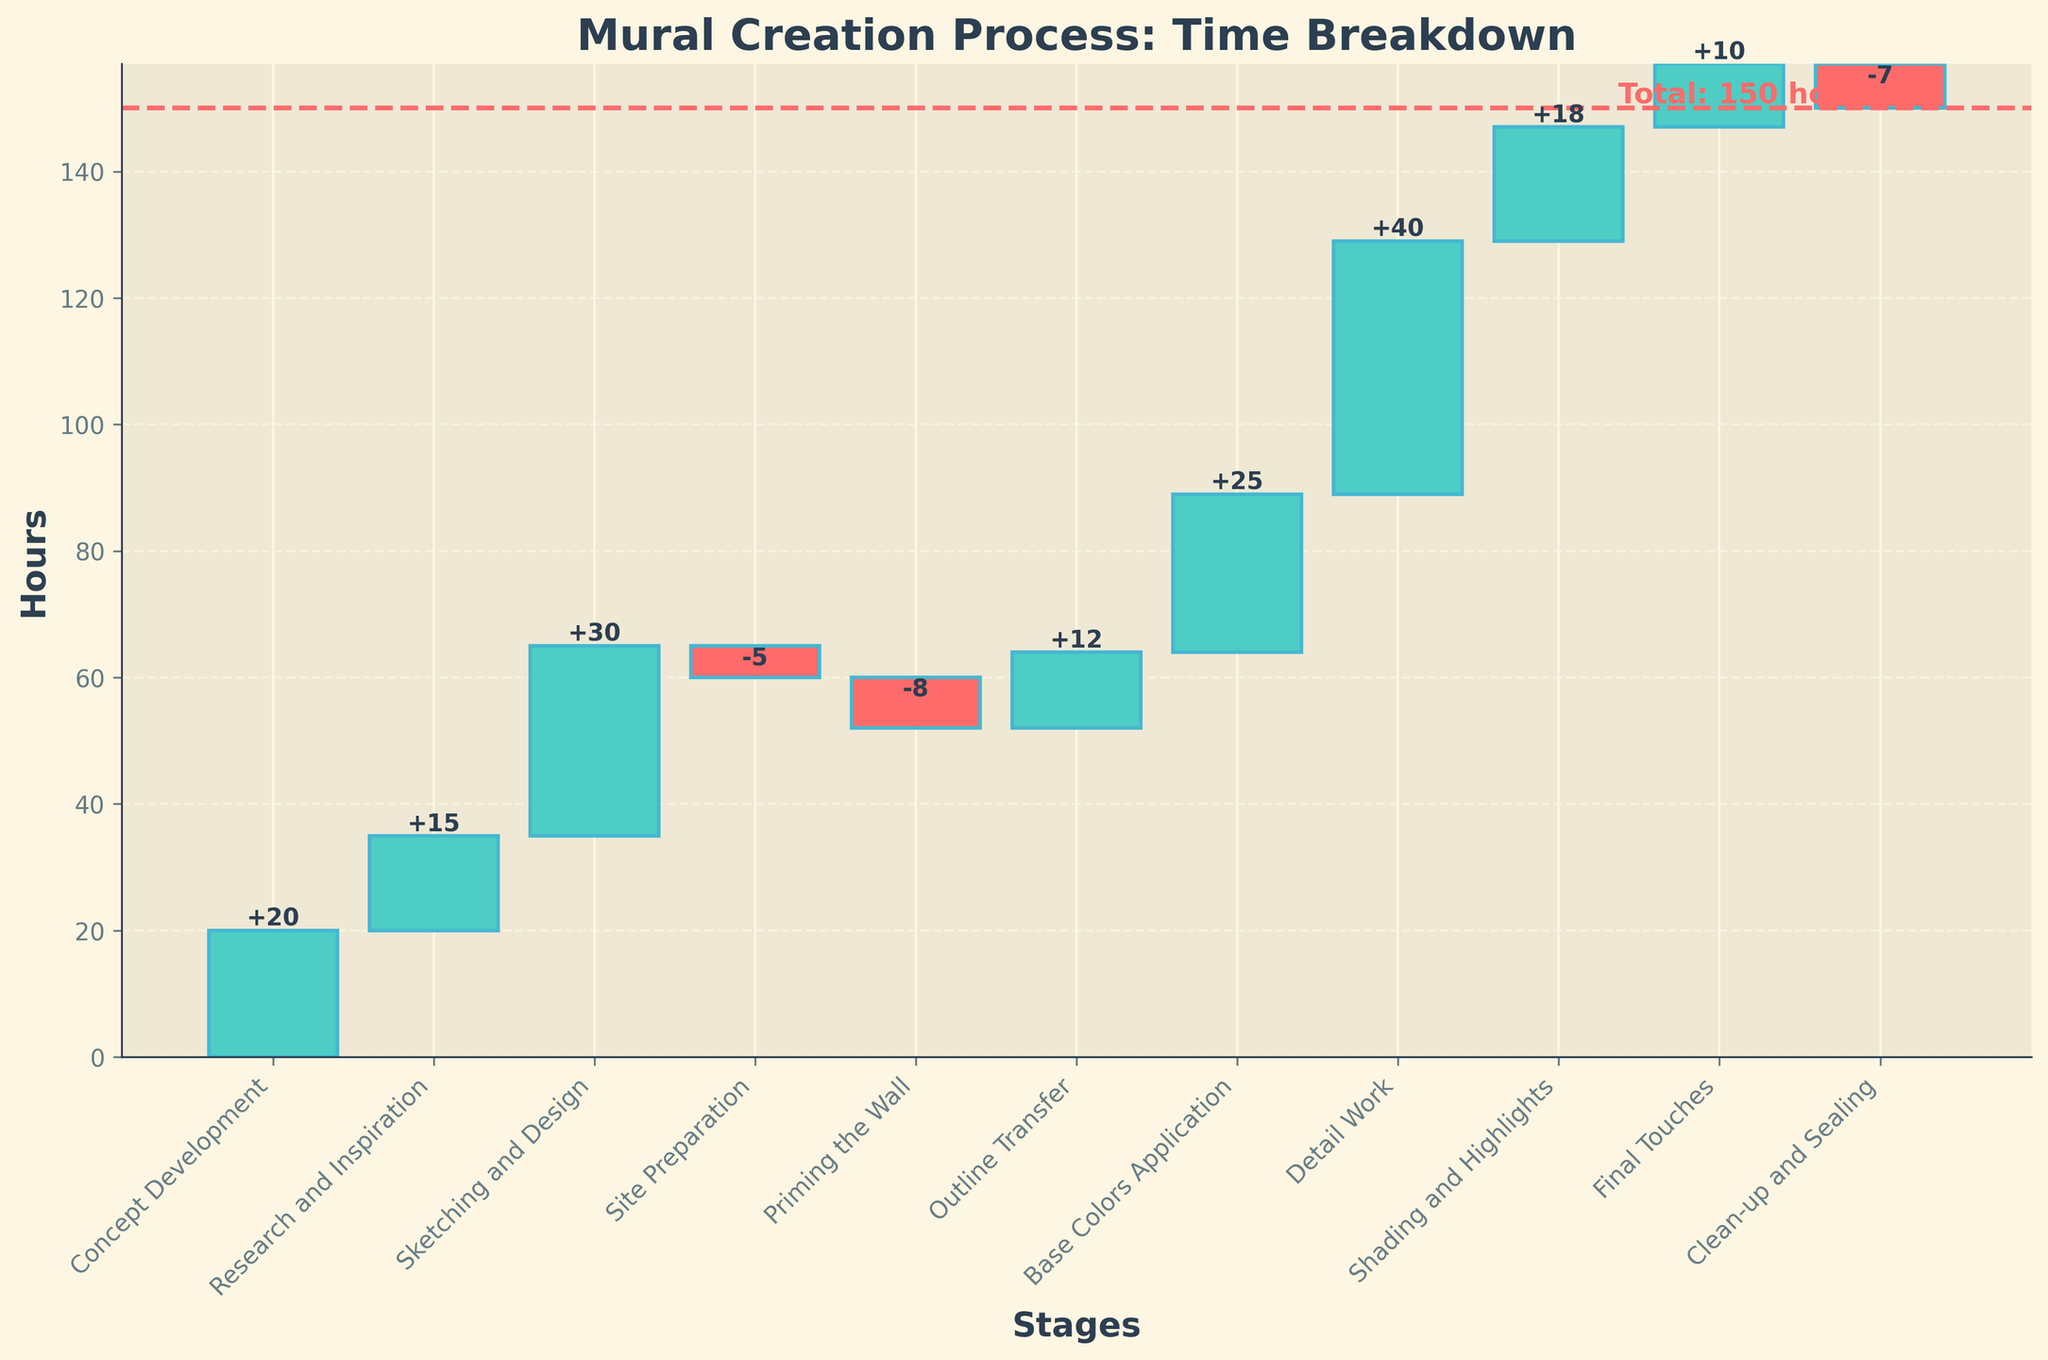What is the title of the chart? The title of the chart is displayed at the top in bold. It reads "Mural Creation Process: Time Breakdown".
Answer: Mural Creation Process: Time Breakdown How many stages are there in the mural creation process according to the chart? To find the number of stages, count the number of bars or stage labels on the x-axis. There are 11 stages listed in the chart.
Answer: 11 Which stage requires the most time? To identify the stage that requires the most time, look for the tallest positive bar. The "Detail Work" stage has the highest positive value of 40 hours.
Answer: Detail Work Which stage has the highest negative value? The highest negative value corresponds to the bar that extends the furthest down. The "Priming the Wall" stage has the most negative hours with -8.
Answer: Priming the Wall What is the cumulative time spent till the end of the "Base Colors Application" stage? To find the cumulative time, sum up the hours sequentially up to the "Base Colors Application" stage: 20 (Concept Development) + 15 (Research and Inspiration) + 30 (Sketching and Design) - 5 (Site Preparation) - 8 (Priming the Wall) + 12 (Outline Transfer) + 25 (Base Colors Application) = 89 hours.
Answer: 89 hours What is the final total time spent on the mural creation process? The final total time is indicated by the horizontal line at the end, labeled with "Total: 150 hours".
Answer: 150 hours What is the cumulative time after the "Shading and Highlights" stage? Calculate the cumulative time by summing up the hours till the "Shading and Highlights" stage: 20 + 15 + 30 - 5 - 8 + 12 + 25 + 40 + 18 = 147 hours.
Answer: 147 hours Between which two stages does the largest increase in hours occur? The largest increase in hours occurs between the stages with the largest difference in bar height. The increase from "Base Colors Application" (25) to "Detail Work" (40) is the largest, equal to 15 hours.
Answer: Base Colors Application to Detail Work Which stage is immediately followed by a decrease in hours? A decrease in hours is represented by a negative bar following a stage. The "Sketching and Design" stage (30) is immediately followed by "Site Preparation" with -5 hours.
Answer: Sketching and Design What is the net time change after "Clean-up and Sealing"? The net time change can be found by summing up all the hours until "Clean-up and Sealing": 20 + 15 + 30 - 5 - 8 + 12 + 25 + 40 + 18 + 10 - 7 = 150 hours. Note the "Clean-up and Sealing" removes 7 hours, affecting the total time at the end.
Answer: 150 hours 